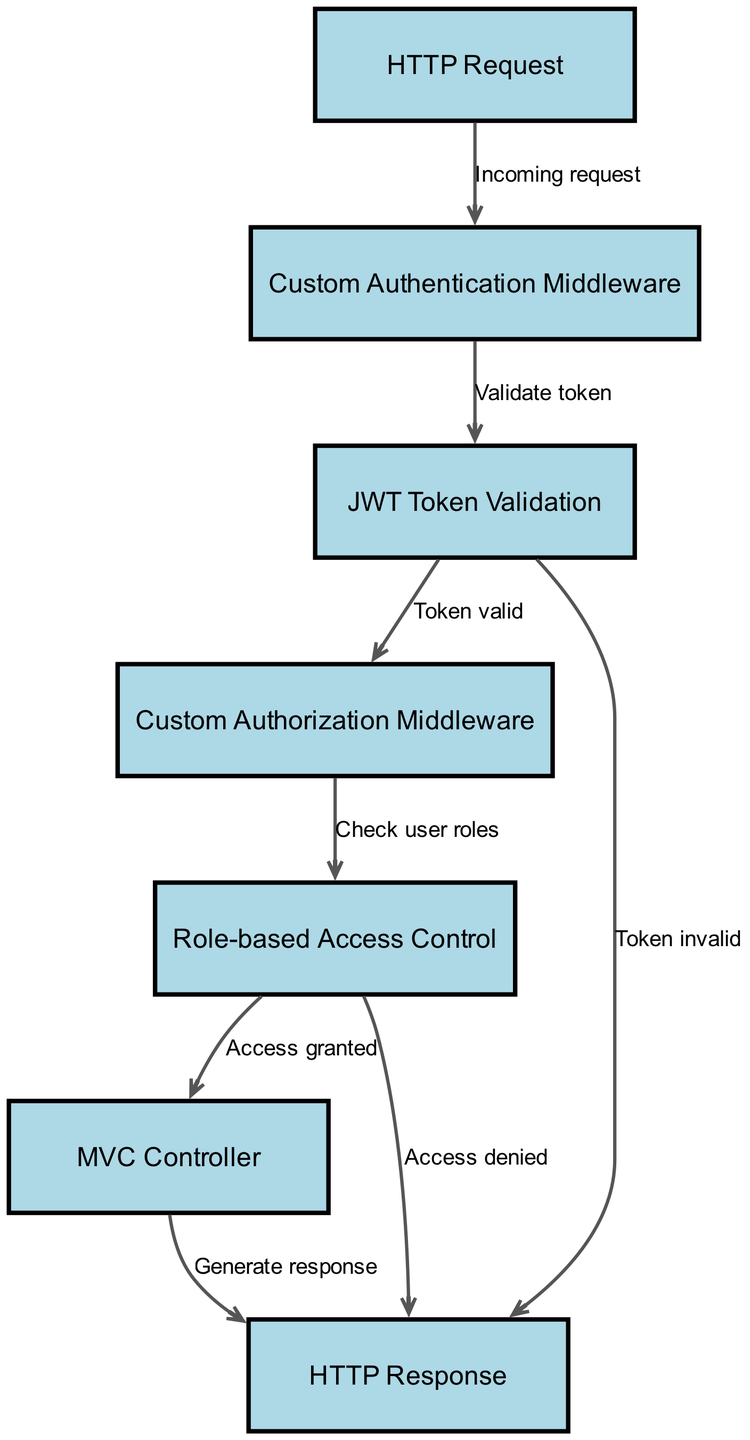What is the first node in the pipeline? The first node in the pipeline is the "HTTP Request," which represents the entry point of incoming requests to the ASP.NET Core application.
Answer: HTTP Request How many nodes are there in the diagram? The diagram contains a total of 7 nodes, which include HTTP Request, Custom Authentication Middleware, JWT Token Validation, Custom Authorization Middleware, Role-based Access Control, MVC Controller, and HTTP Response.
Answer: 7 What happens if the token is invalid? If the token is invalid, the flow goes directly from "JWT Token Validation" to "HTTP Response," indicating that no further processing occurs for valid access, and the response is generated indicating the token's invalidity.
Answer: Token invalid What is the result of passing through the "Custom Authentication Middleware"? Upon passing through the "Custom Authentication Middleware," the process transitions to "JWT Token Validation," which indicates that the authentication process includes a step for validating the JWT token.
Answer: Validate token Which node represents the final output of the pipeline? The final output of the pipeline is represented by the "HTTP Response," which is the result returned to the client after processing the request, whether access was granted or denied.
Answer: HTTP Response What checks are performed after JWT Token Validation? After JWT Token Validation, the next check performed is in the "Custom Authorization Middleware" to determine user access permissions based on roles.
Answer: Check user roles What indicates successful access to the MVC Controller? Successful access to the MVC Controller is indicated by the flow from "Role-based Access Control" to "MVC Controller," marked by the label "Access granted," which shows the user has the required roles to access the controller.
Answer: Access granted What occurs when access is denied due to roles? When access is denied due to roles, the process jumps from "Role-based Access Control" directly to "HTTP Response," indicating that the request cannot proceed to the MVC Controller, and a denial message is sent back to the client.
Answer: Access denied 